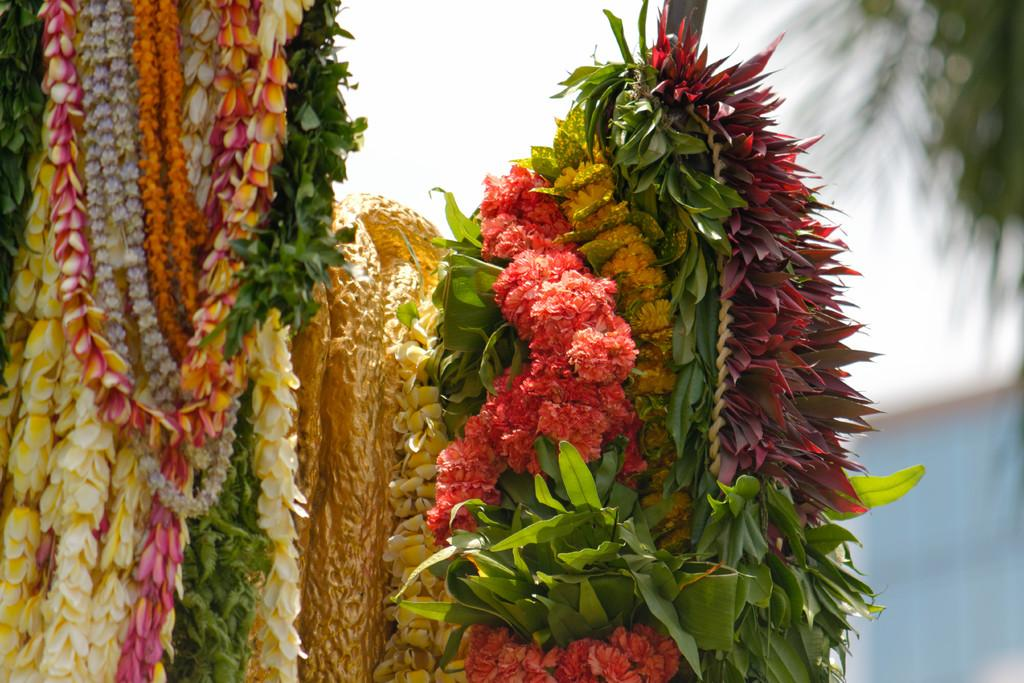What type of decorative items are present in the image? There is a group of garlands of flowers and leaves in the image. What can be seen in the background of the image? The sky is visible at the top of the image. Where is the tree located in the image? There is a tree in the top right corner of the image. What type of creature is exhibiting unusual behavior in the image? There is no creature present in the image, and therefore no behavior can be observed. What type of plough is being used to cultivate the land in the image? There is no plough present in the image; it features a group of garlands, the sky, and a tree. 